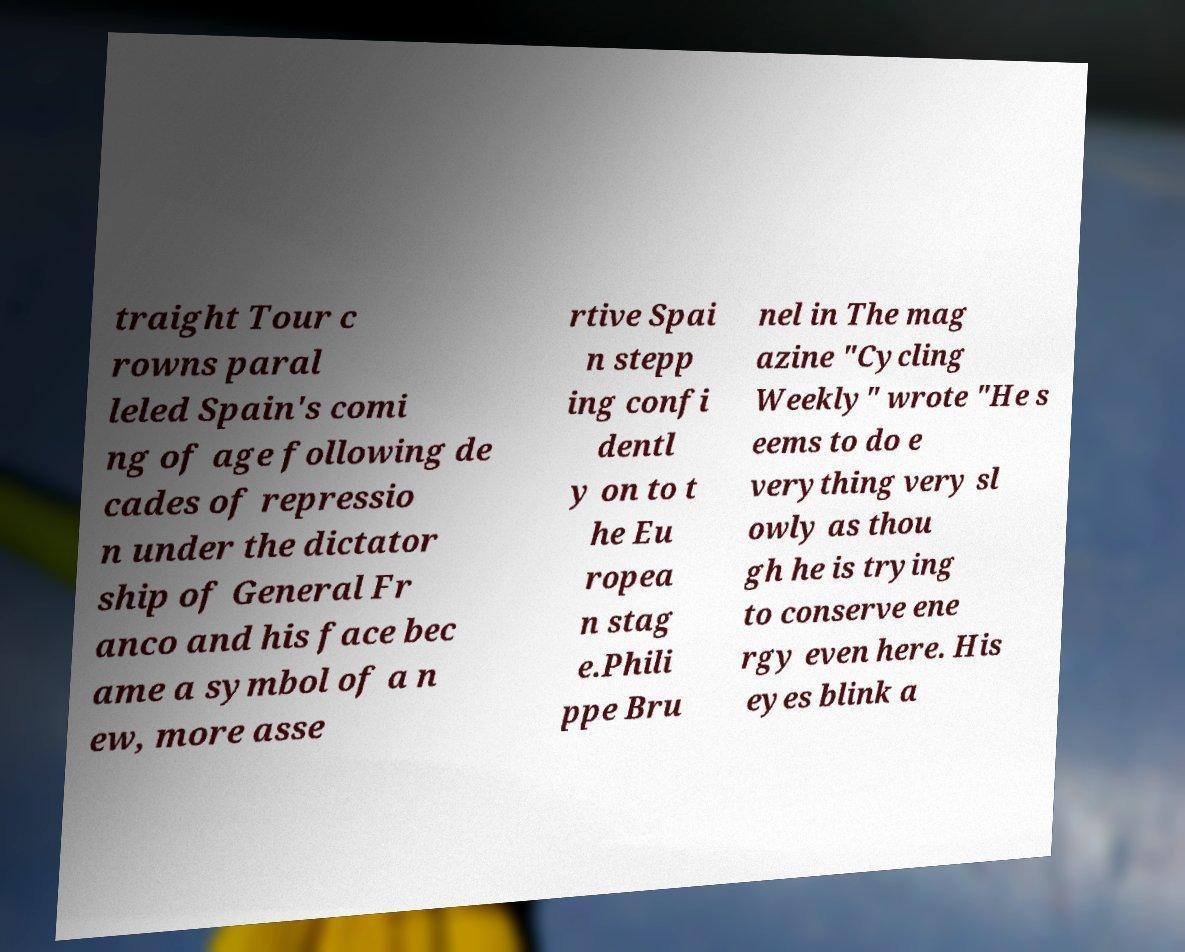What messages or text are displayed in this image? I need them in a readable, typed format. traight Tour c rowns paral leled Spain's comi ng of age following de cades of repressio n under the dictator ship of General Fr anco and his face bec ame a symbol of a n ew, more asse rtive Spai n stepp ing confi dentl y on to t he Eu ropea n stag e.Phili ppe Bru nel in The mag azine "Cycling Weekly" wrote "He s eems to do e verything very sl owly as thou gh he is trying to conserve ene rgy even here. His eyes blink a 